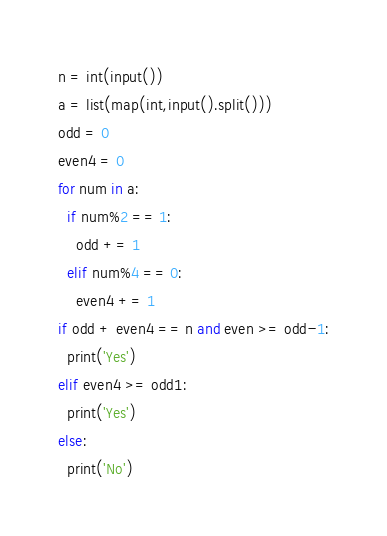<code> <loc_0><loc_0><loc_500><loc_500><_Python_>n = int(input())
a = list(map(int,input().split()))
odd = 0
even4 = 0
for num in a:
  if num%2 == 1:
    odd += 1
  elif num%4 == 0:
    even4 += 1
if odd + even4 == n and even >= odd-1:
  print('Yes')
elif even4 >= odd1:
  print('Yes')
else:
  print('No')</code> 